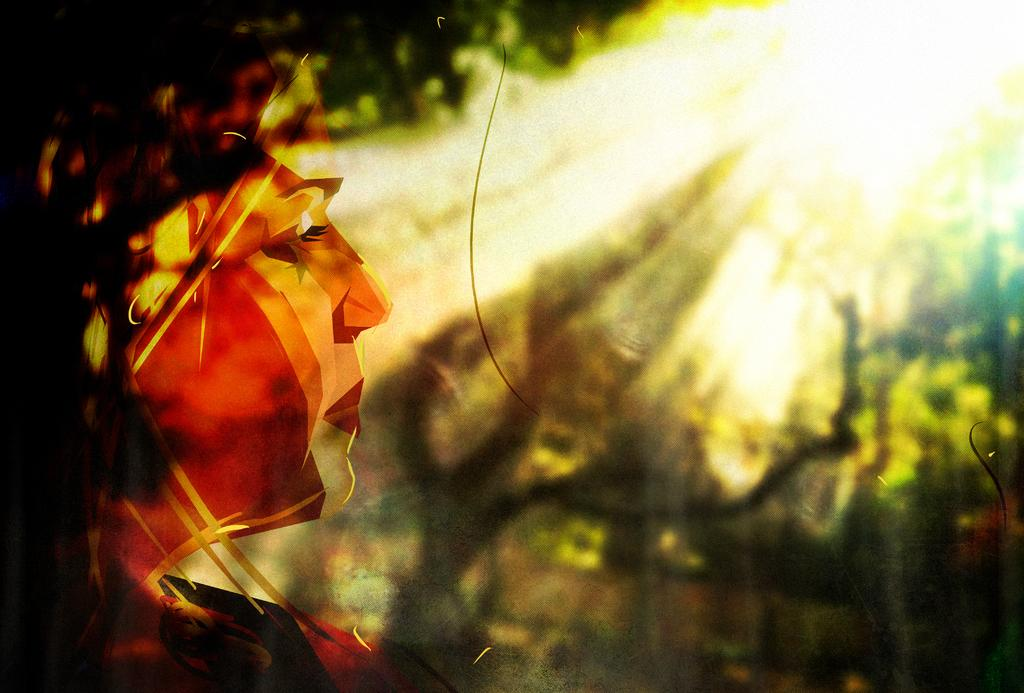What is depicted on the left side of the image? There is a portrait of a lady on the left side of the image. Can you describe the subject of the portrait? The portrait is of a lady. What type of scenery can be seen on the right side of the image? There is greenery on the right side of the image. How many eyes does the goat have in the image? There is no goat present in the image. What is the rate of the lady's portrait in the image? The question does not make sense, as the portrait is a static image and cannot have a rate. 